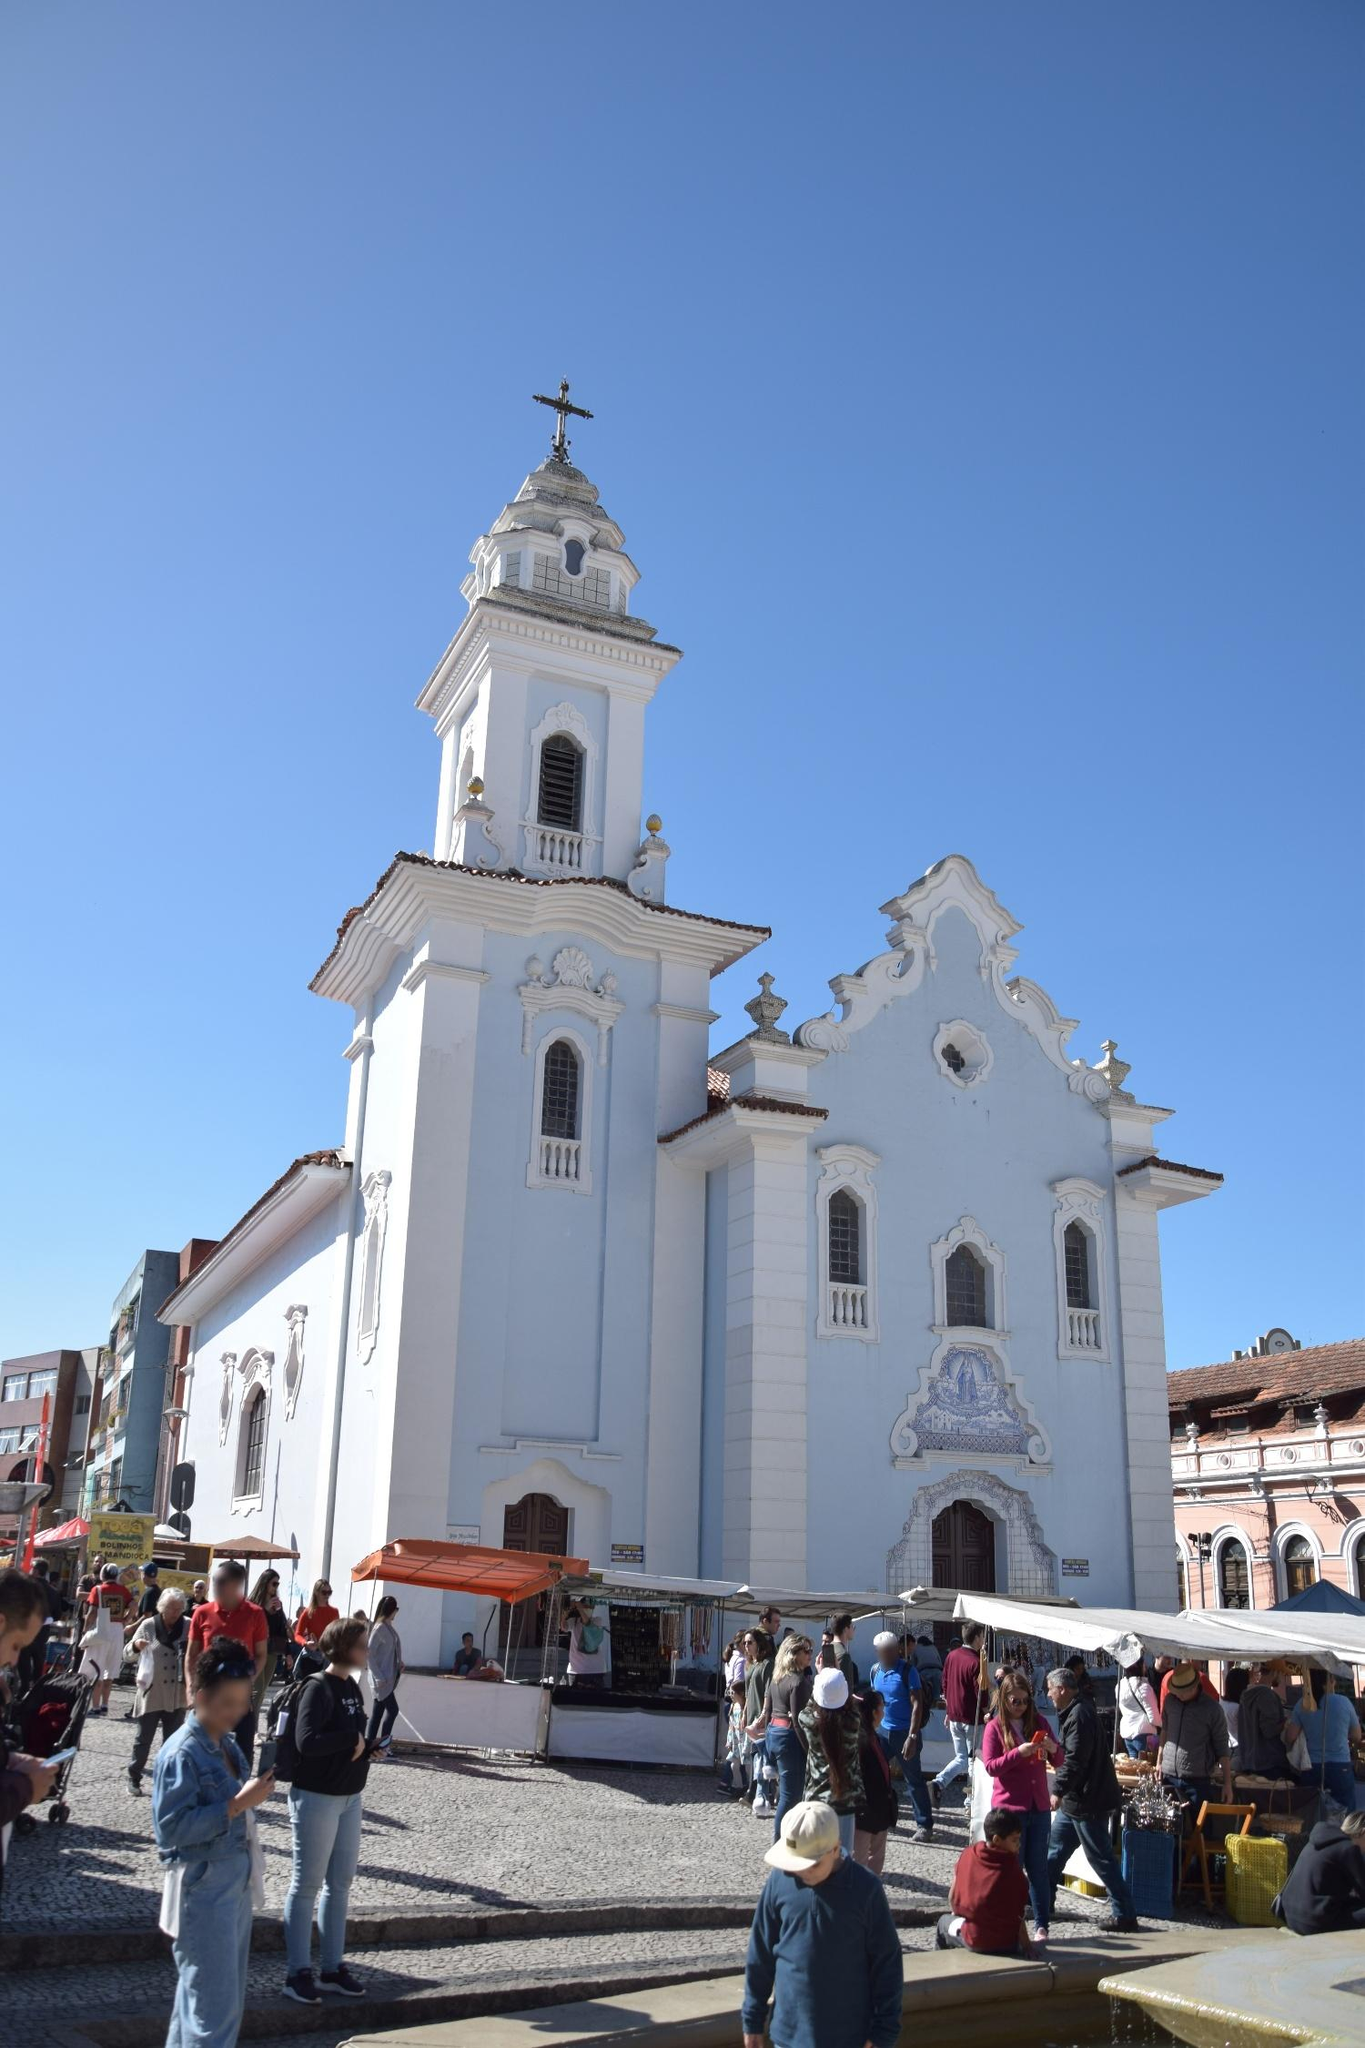What are the key elements in this picture? The image highlights the Igreja de Nossa Senhora do Rosário dos Pretos, a historic church situated in Salvador, Brazil. Dominating the scene, the pristine white-painted church stands majestically against a vibrant blue sky. The photograph captures the structure from a low angle, further emphasizing the church's impressive stature. Noteworthy features include the left-sided bell tower, a cross atop it, and an ornate facade with a grand archway. Above the main entrance, there's a smaller arch, accentuating the church's elaborate design. The scene is bustling with activity; people gather in the foreground, while vendors display their goods, giving a lively and authentic glimpse into the daily life around this revered landmark. 